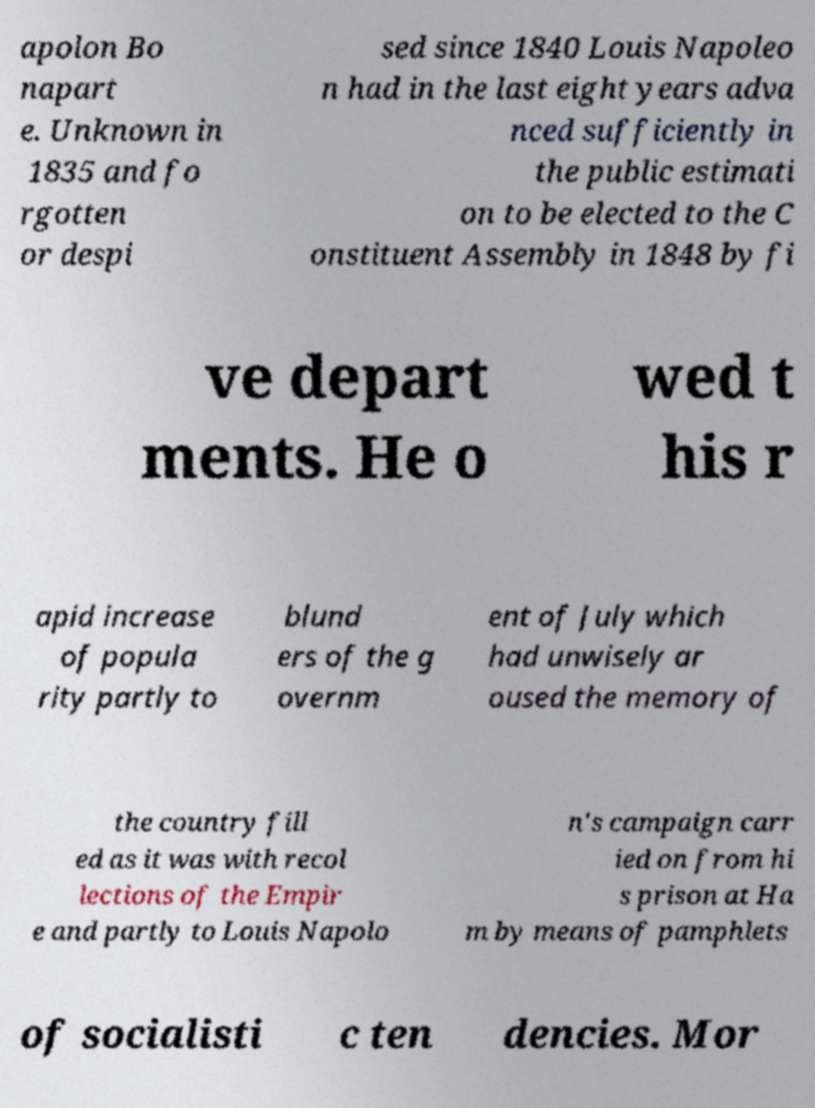I need the written content from this picture converted into text. Can you do that? apolon Bo napart e. Unknown in 1835 and fo rgotten or despi sed since 1840 Louis Napoleo n had in the last eight years adva nced sufficiently in the public estimati on to be elected to the C onstituent Assembly in 1848 by fi ve depart ments. He o wed t his r apid increase of popula rity partly to blund ers of the g overnm ent of July which had unwisely ar oused the memory of the country fill ed as it was with recol lections of the Empir e and partly to Louis Napolo n's campaign carr ied on from hi s prison at Ha m by means of pamphlets of socialisti c ten dencies. Mor 